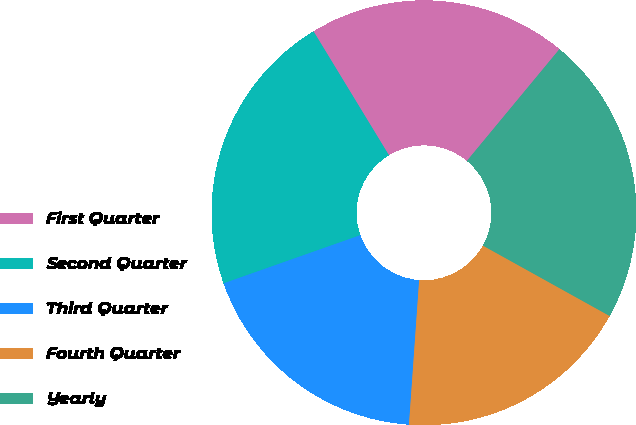<chart> <loc_0><loc_0><loc_500><loc_500><pie_chart><fcel>First Quarter<fcel>Second Quarter<fcel>Third Quarter<fcel>Fourth Quarter<fcel>Yearly<nl><fcel>19.71%<fcel>21.69%<fcel>18.49%<fcel>18.05%<fcel>22.06%<nl></chart> 